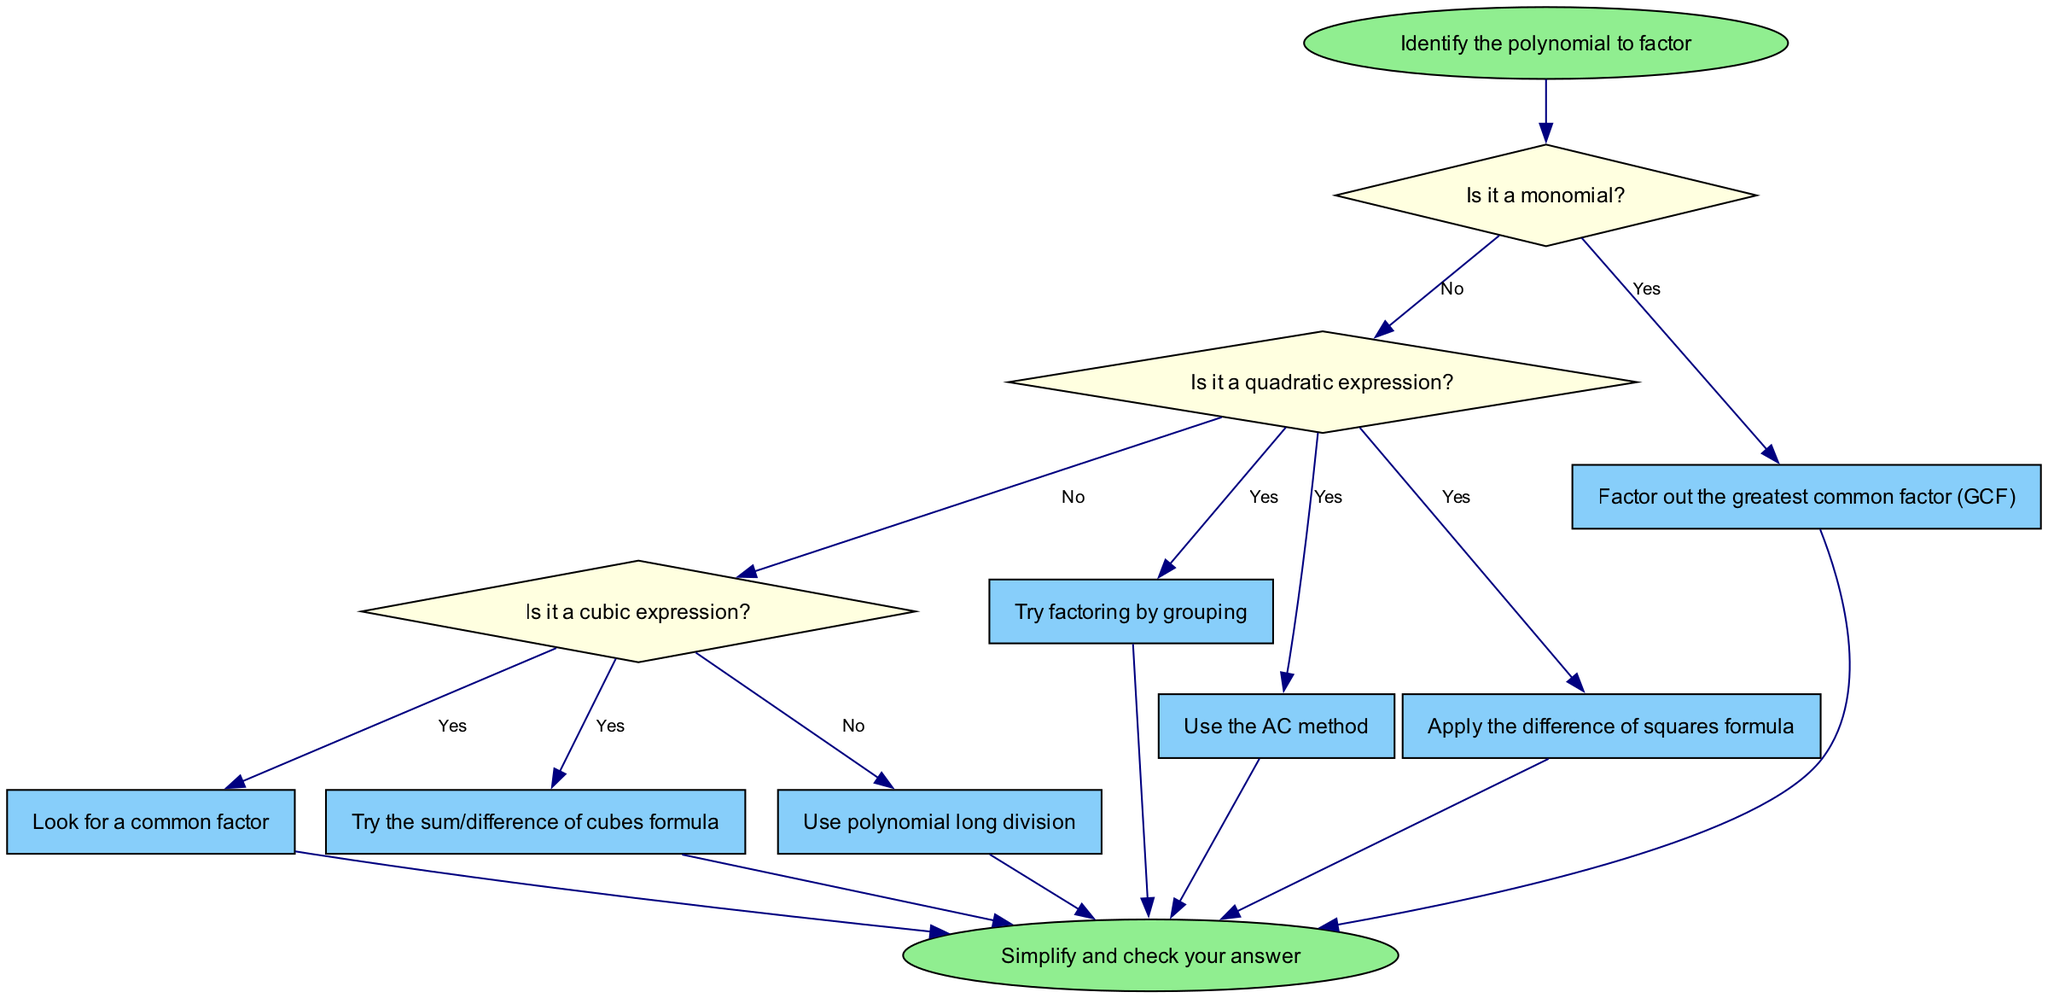What is the first step in the flowchart? The flowchart starts with the instruction to "Identify the polynomial to factor." This is clearly stated in the starting node of the diagram, indicating that this is the initial action to be taken.
Answer: Identify the polynomial to factor How many decisions are in the flowchart? The flowchart contains three decision nodes: "Is it a monomial?", "Is it a quadratic expression?", and "Is it a cubic expression?". Counting these nodes directly from the diagram yields the total.
Answer: Three What should you do if the polynomial is a monomial? If the polynomial is a monomial, the action specified is to "Factor out the greatest common factor (GCF)." This is a direct action that follows the decision node regarding monomials.
Answer: Factor out the greatest common factor (GCF) What method is suggested for cubic expressions? The flowchart provides two methods for cubic expressions: "Look for a common factor" and "Try the sum/difference of cubes formula." Both actions follow the decision node for cubic expressions, indicating different possible strategies.
Answer: Look for a common factor or Try the sum/difference of cubes formula If the polynomial is quadratic, what are the possible actions to factor it? The flowchart indicates that for quadratic expressions, one can "Try factoring by grouping," "Use the AC method," or "Apply the difference of squares formula." These are all possible actions to take after identifying a quadratic expression.
Answer: Try factoring by grouping, Use the AC method, or Apply the difference of squares formula What happens after all actions are completed? Once any of the actions are performed, the flowchart indicates that the next step is to "Simplify and check your answer." This step follows all action nodes and leads to the conclusion of the process.
Answer: Simplify and check your answer Which action follows the decision "Is it a quadratic expression?" if the answer is no? If the polynomial is not quadratic, the flowchart directs to the next decision node, "Is it a cubic expression?" This shows that further classification of the polynomial continues after this "no" response.
Answer: Is it a cubic expression? What color are the decision nodes in the flowchart? The decision nodes are colored light yellow, as indicated by the specified style in the flowchart design. This color helps differentiate decision nodes from action and start/end nodes.
Answer: Light yellow Which action is taken if the polynomial is neither monomial, quadratic, nor cubic? The flowchart does not specify actions for polynomials outside these classifications. The flowchart primarily guides through these specific types, implying that further categories are not addressed.
Answer: No specific action provided 